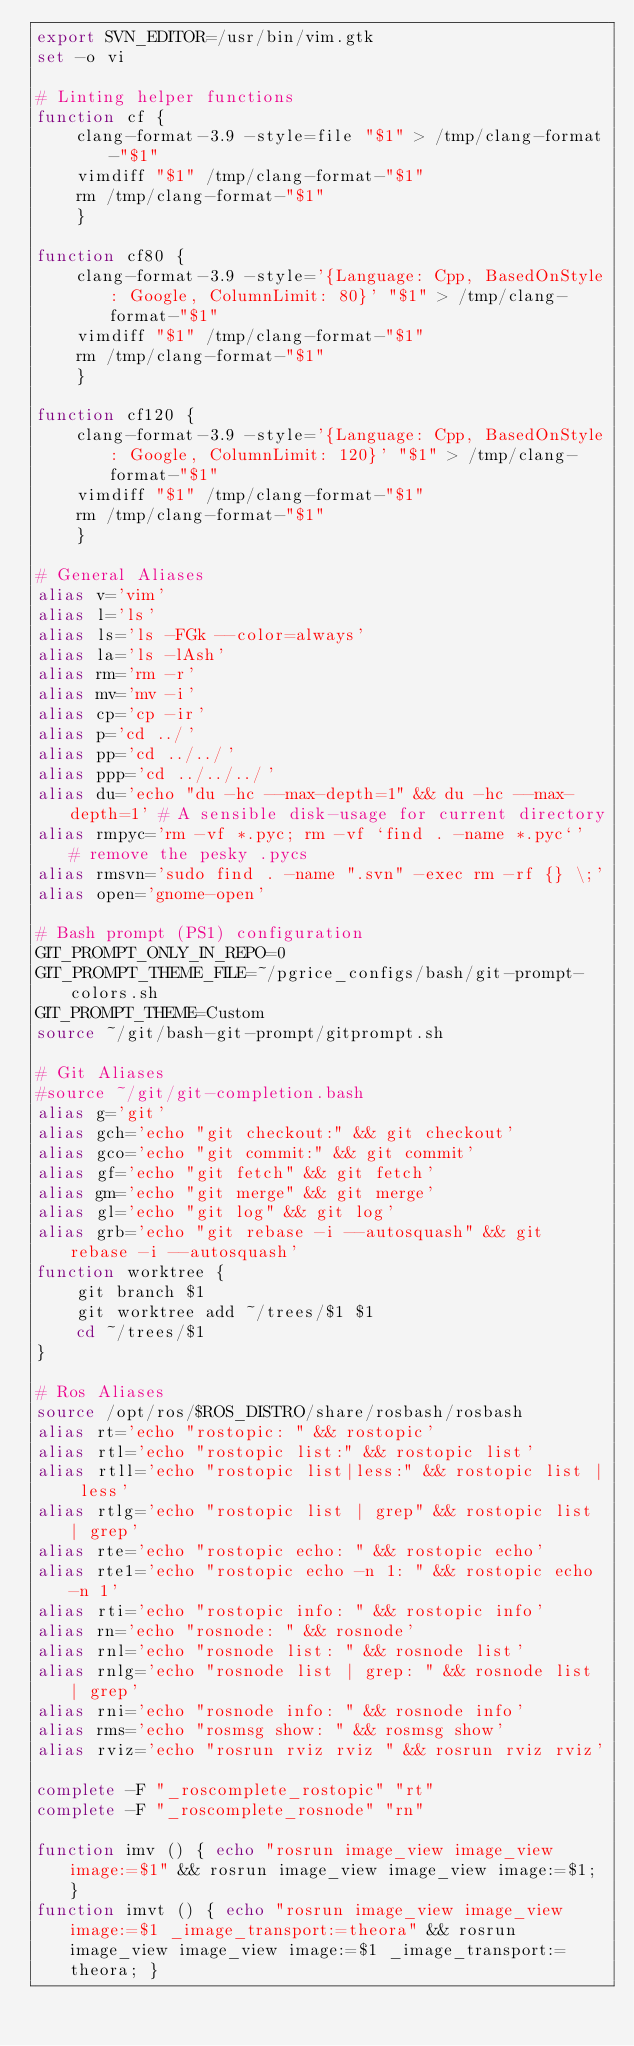Convert code to text. <code><loc_0><loc_0><loc_500><loc_500><_Bash_>export SVN_EDITOR=/usr/bin/vim.gtk
set -o vi

# Linting helper functions
function cf {
    clang-format-3.9 -style=file "$1" > /tmp/clang-format-"$1"
    vimdiff "$1" /tmp/clang-format-"$1"
    rm /tmp/clang-format-"$1"
    }

function cf80 {
    clang-format-3.9 -style='{Language: Cpp, BasedOnStyle: Google, ColumnLimit: 80}' "$1" > /tmp/clang-format-"$1"
    vimdiff "$1" /tmp/clang-format-"$1"
    rm /tmp/clang-format-"$1"
    }

function cf120 {
    clang-format-3.9 -style='{Language: Cpp, BasedOnStyle: Google, ColumnLimit: 120}' "$1" > /tmp/clang-format-"$1"
    vimdiff "$1" /tmp/clang-format-"$1"
    rm /tmp/clang-format-"$1"
    }

# General Aliases
alias v='vim'
alias l='ls'
alias ls='ls -FGk --color=always'
alias la='ls -lAsh'
alias rm='rm -r'
alias mv='mv -i'
alias cp='cp -ir'
alias p='cd ../'
alias pp='cd ../../'
alias ppp='cd ../../../'
alias du='echo "du -hc --max-depth=1" && du -hc --max-depth=1' # A sensible disk-usage for current directory
alias rmpyc='rm -vf *.pyc; rm -vf `find . -name *.pyc`'  # remove the pesky .pycs
alias rmsvn='sudo find . -name ".svn" -exec rm -rf {} \;'
alias open='gnome-open'

# Bash prompt (PS1) configuration
GIT_PROMPT_ONLY_IN_REPO=0
GIT_PROMPT_THEME_FILE=~/pgrice_configs/bash/git-prompt-colors.sh
GIT_PROMPT_THEME=Custom
source ~/git/bash-git-prompt/gitprompt.sh

# Git Aliases
#source ~/git/git-completion.bash
alias g='git'
alias gch='echo "git checkout:" && git checkout'
alias gco='echo "git commit:" && git commit'
alias gf='echo "git fetch" && git fetch'
alias gm='echo "git merge" && git merge'
alias gl='echo "git log" && git log'
alias grb='echo "git rebase -i --autosquash" && git rebase -i --autosquash'
function worktree {
    git branch $1
    git worktree add ~/trees/$1 $1
    cd ~/trees/$1
}

# Ros Aliases
source /opt/ros/$ROS_DISTRO/share/rosbash/rosbash
alias rt='echo "rostopic: " && rostopic'
alias rtl='echo "rostopic list:" && rostopic list'
alias rtll='echo "rostopic list|less:" && rostopic list | less'
alias rtlg='echo "rostopic list | grep" && rostopic list | grep'
alias rte='echo "rostopic echo: " && rostopic echo'
alias rte1='echo "rostopic echo -n 1: " && rostopic echo -n 1'
alias rti='echo "rostopic info: " && rostopic info'
alias rn='echo "rosnode: " && rosnode'
alias rnl='echo "rosnode list: " && rosnode list'
alias rnlg='echo "rosnode list | grep: " && rosnode list | grep'
alias rni='echo "rosnode info: " && rosnode info'
alias rms='echo "rosmsg show: " && rosmsg show'
alias rviz='echo "rosrun rviz rviz " && rosrun rviz rviz'

complete -F "_roscomplete_rostopic" "rt"
complete -F "_roscomplete_rosnode" "rn"

function imv () { echo "rosrun image_view image_view image:=$1" && rosrun image_view image_view image:=$1; }
function imvt () { echo "rosrun image_view image_view image:=$1 _image_transport:=theora" && rosrun image_view image_view image:=$1 _image_transport:=theora; }

</code> 